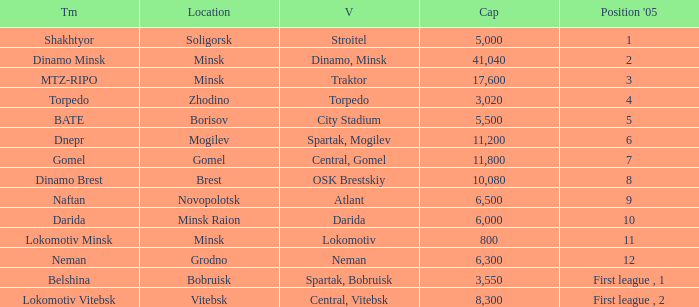Can you tell me the Venue that has the Position in 2005 of 8? OSK Brestskiy. 